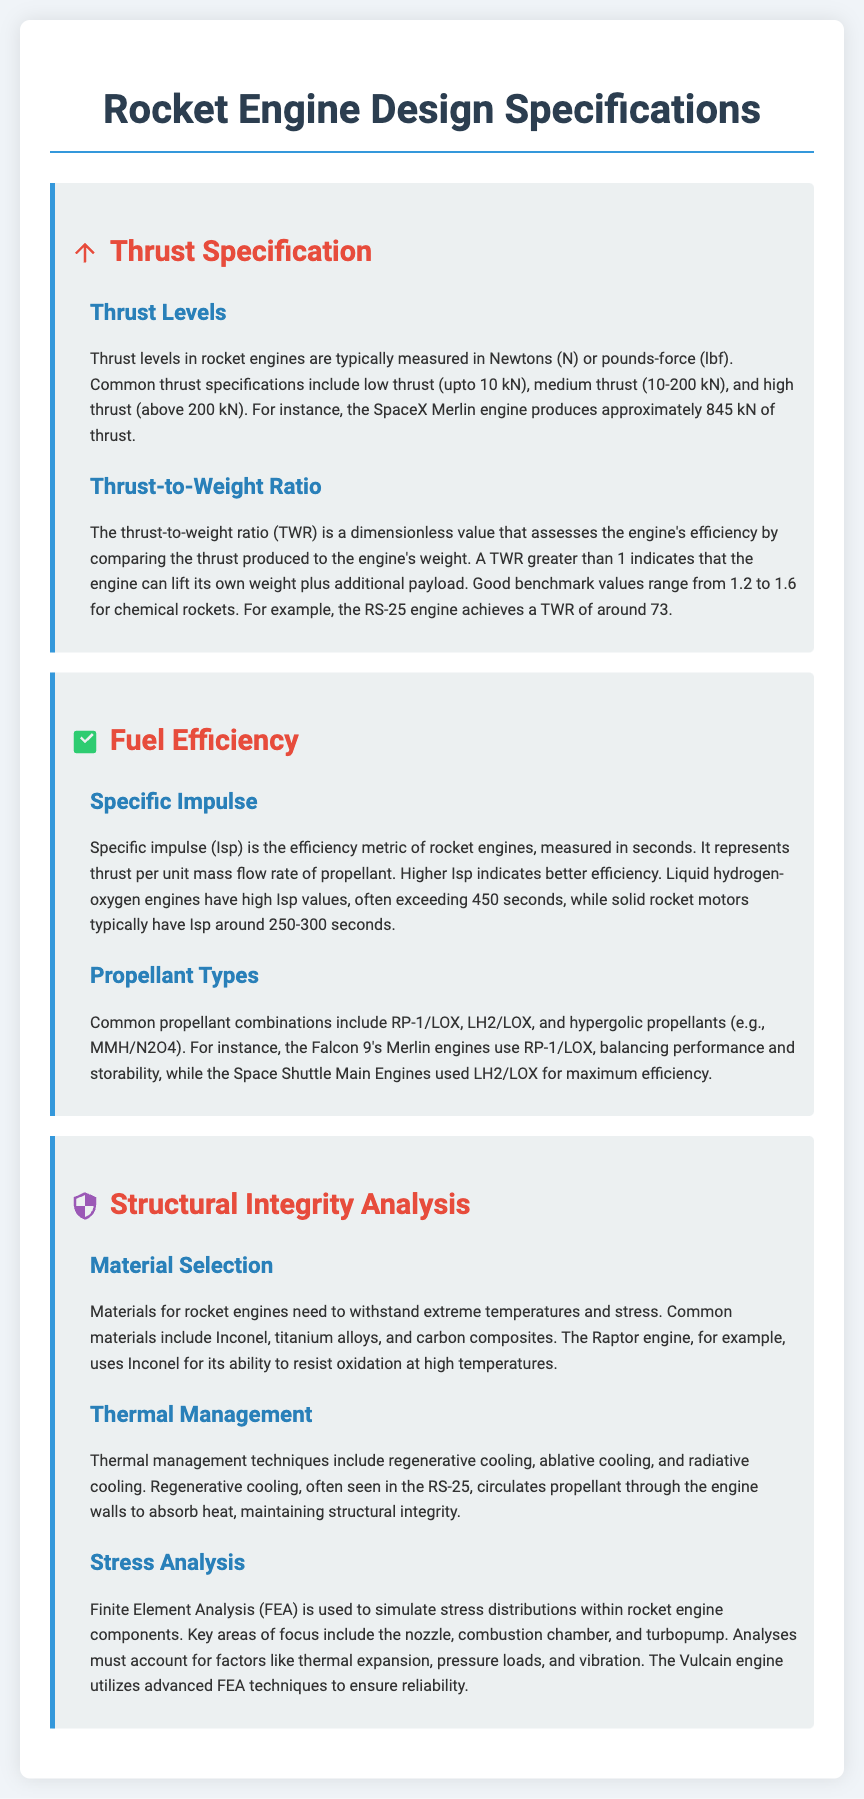What is the thrust level range for low thrust engines? Low thrust is defined as up to 10 kN.
Answer: up to 10 kN What is the thrust-to-weight ratio benchmark for chemical rockets? Good benchmark values for thrust-to-weight ratio range from 1.2 to 1.6.
Answer: 1.2 to 1.6 What is the specific impulse of liquid hydrogen-oxygen engines? Liquid hydrogen-oxygen engines have high specific impulse values, often exceeding 450 seconds.
Answer: exceeding 450 seconds What is a common propellant combination used in the Falcon 9? The Falcon 9's Merlin engines use RP-1/LOX.
Answer: RP-1/LOX Which material is commonly used in the Raptor engine? The Raptor engine uses Inconel for its ability to resist oxidation at high temperatures.
Answer: Inconel What thermal management technique is often used in the RS-25 engine? Regenerative cooling is often seen in the RS-25.
Answer: Regenerative cooling What analysis technique is used to simulate stress distributions in rocket engine components? Finite Element Analysis (FEA) is used to simulate stress distributions.
Answer: Finite Element Analysis (FEA) What maximum thrust does the SpaceX Merlin engine produce? The SpaceX Merlin engine produces approximately 845 kN of thrust.
Answer: approximately 845 kN What is the specific impulse range for solid rocket motors? Solid rocket motors typically have specific impulse around 250-300 seconds.
Answer: 250-300 seconds 